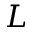<formula> <loc_0><loc_0><loc_500><loc_500>L</formula> 